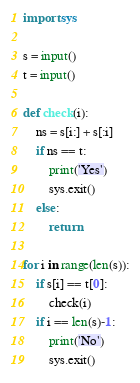<code> <loc_0><loc_0><loc_500><loc_500><_Python_>import sys

s = input()
t = input()

def check(i):
	ns = s[i:] + s[:i]
	if ns == t:
		print('Yes')
		sys.exit()
	else:
		return

for i in range(len(s)):
	if s[i] == t[0]:
		check(i)
	if i == len(s)-1:
		print('No')
		sys.exit()

</code> 